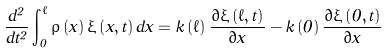<formula> <loc_0><loc_0><loc_500><loc_500>\frac { d ^ { 2 } } { d t ^ { 2 } } \int _ { 0 } ^ { \ell } \rho \left ( x \right ) \xi \left ( x , t \right ) d x = k \left ( \ell \right ) \frac { \partial \xi \left ( \ell , t \right ) } { \partial x } - k \left ( 0 \right ) \frac { \partial \xi \left ( 0 , t \right ) } { \partial x }</formula> 